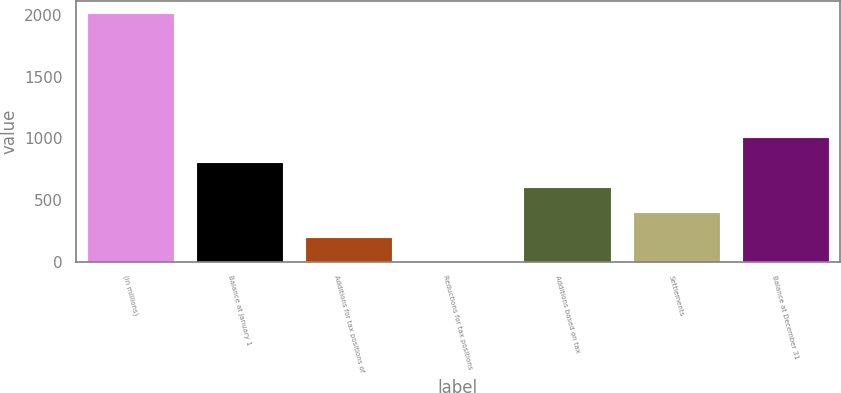Convert chart to OTSL. <chart><loc_0><loc_0><loc_500><loc_500><bar_chart><fcel>(in millions)<fcel>Balance at January 1<fcel>Additions for tax positions of<fcel>Reductions for tax positions<fcel>Additions based on tax<fcel>Settlements<fcel>Balance at December 31<nl><fcel>2012<fcel>805.4<fcel>202.1<fcel>1<fcel>604.3<fcel>403.2<fcel>1006.5<nl></chart> 